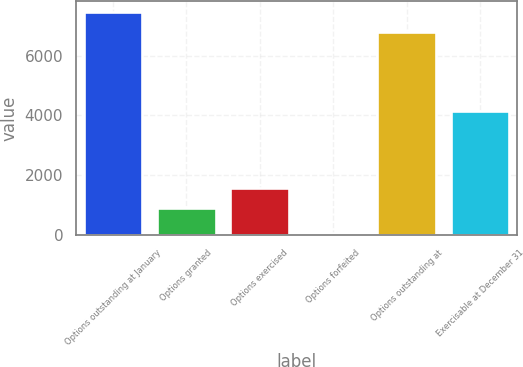Convert chart. <chart><loc_0><loc_0><loc_500><loc_500><bar_chart><fcel>Options outstanding at January<fcel>Options granted<fcel>Options exercised<fcel>Options forfeited<fcel>Options outstanding at<fcel>Exercisable at December 31<nl><fcel>7466.8<fcel>905<fcel>1586.8<fcel>77<fcel>6785<fcel>4159<nl></chart> 